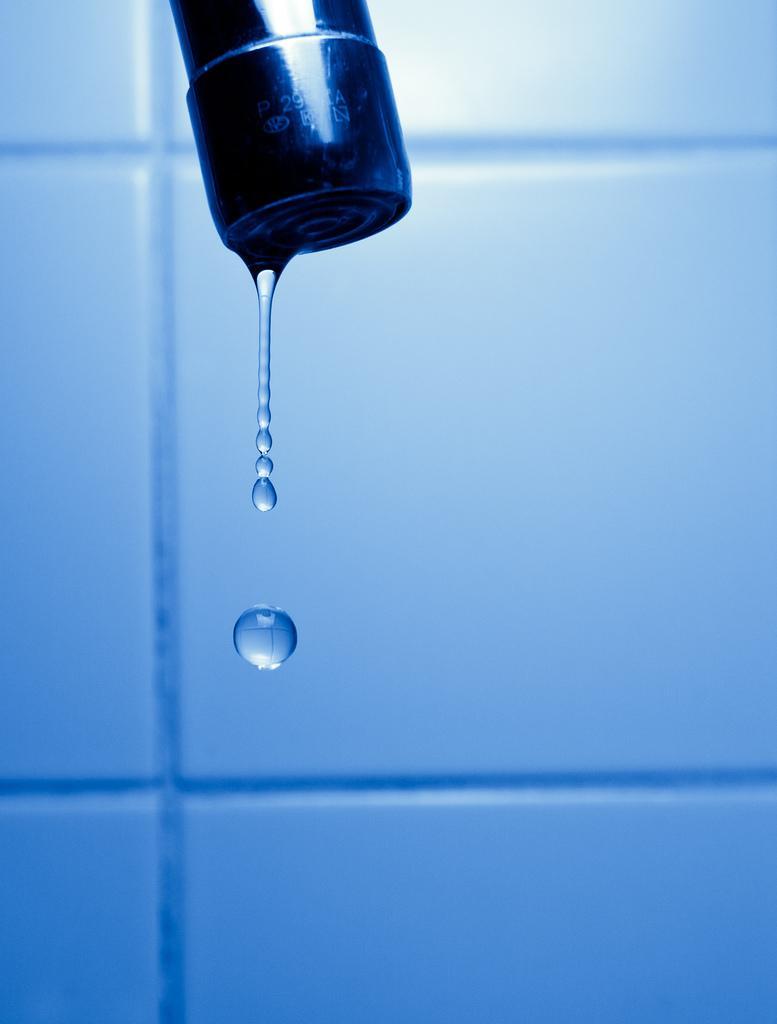In one or two sentences, can you explain what this image depicts? In the center of the picture there is a tap, through the tap we can see water droplets coming out. In the background it is well. 